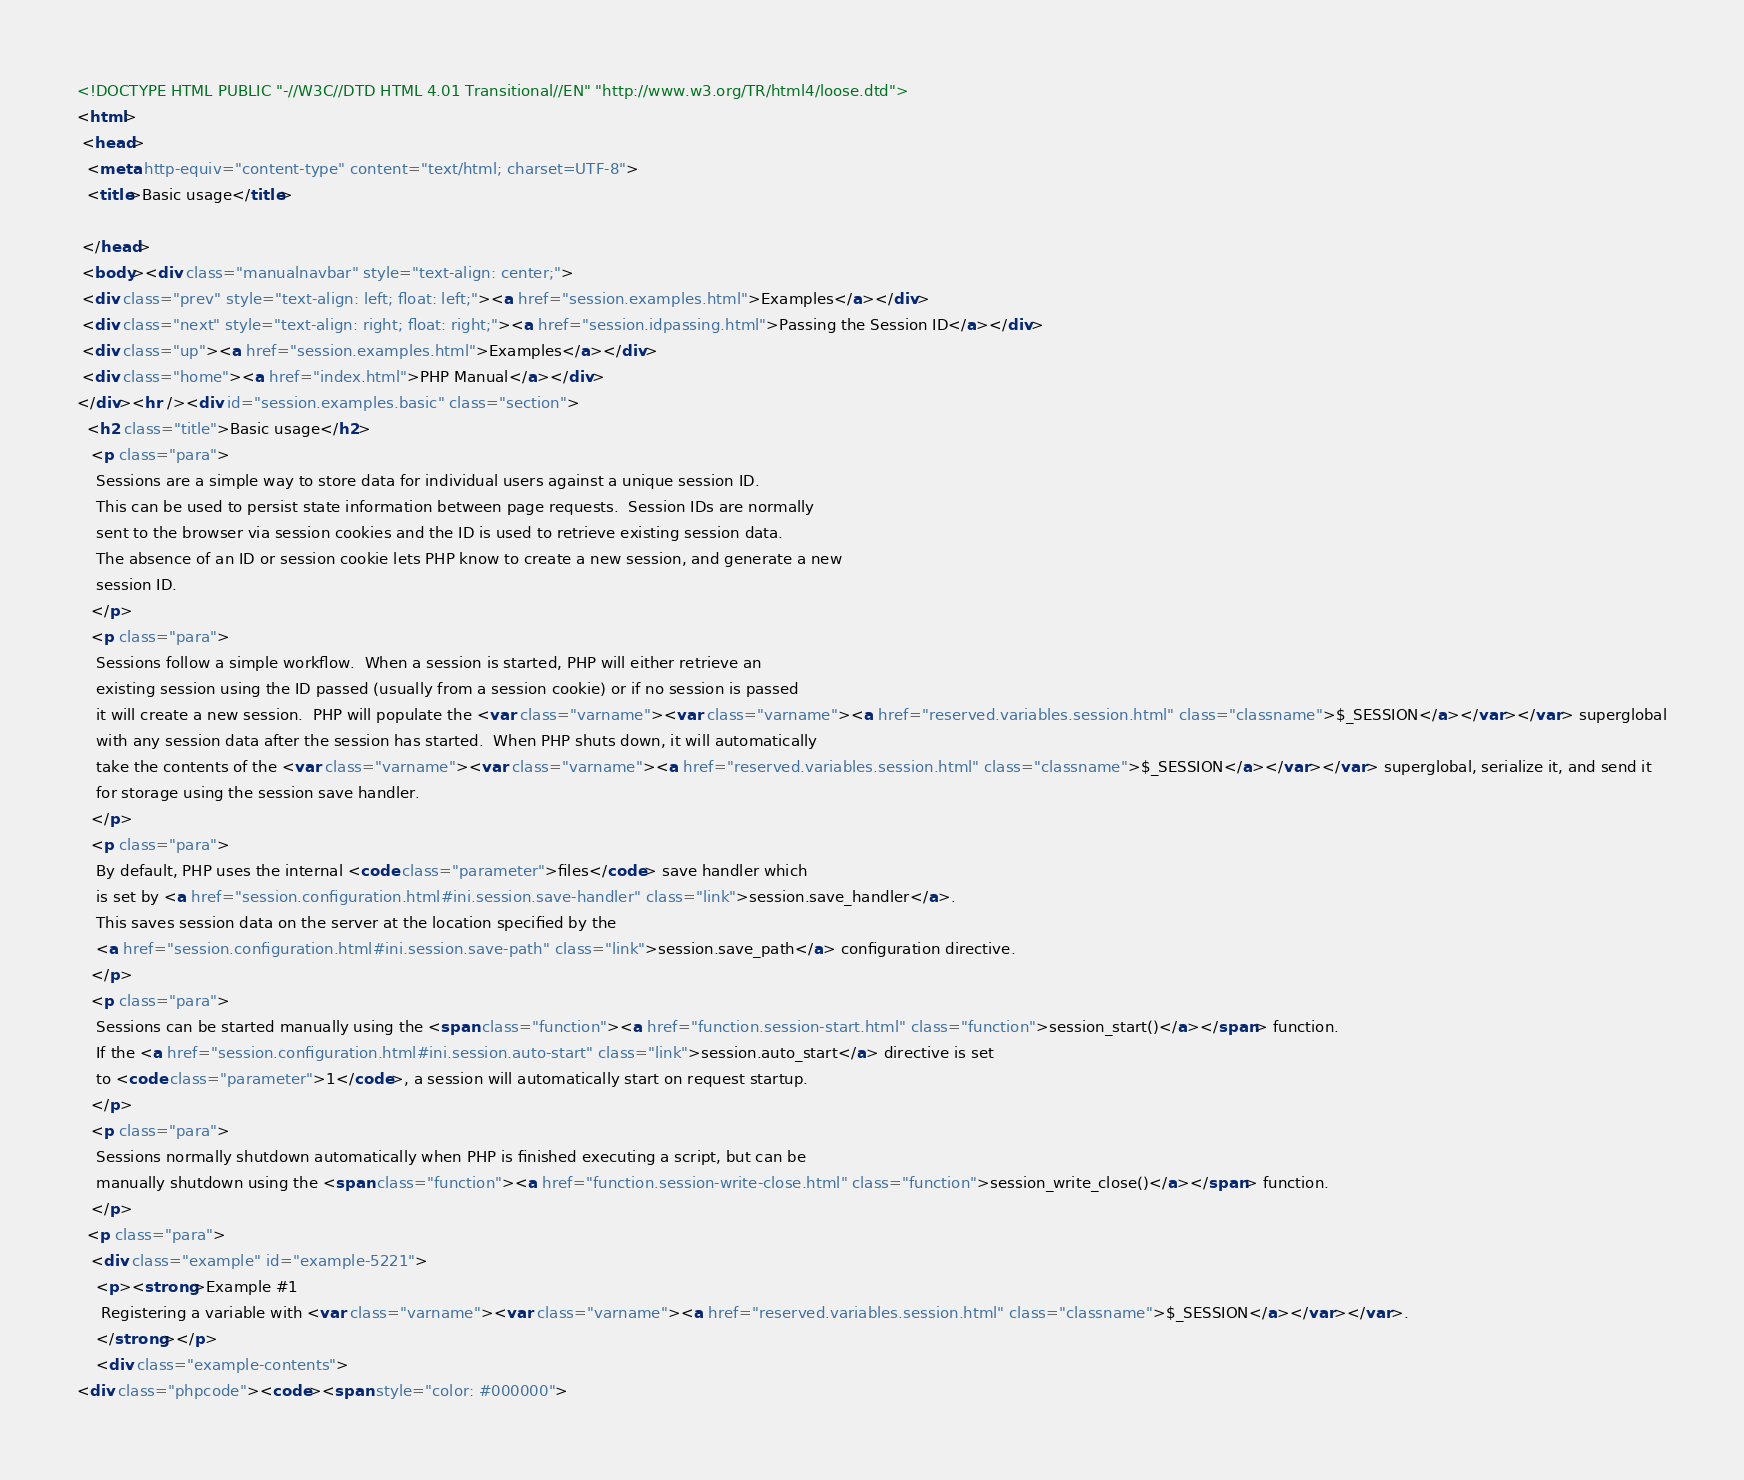<code> <loc_0><loc_0><loc_500><loc_500><_HTML_><!DOCTYPE HTML PUBLIC "-//W3C//DTD HTML 4.01 Transitional//EN" "http://www.w3.org/TR/html4/loose.dtd">
<html>
 <head>
  <meta http-equiv="content-type" content="text/html; charset=UTF-8">
  <title>Basic usage</title>

 </head>
 <body><div class="manualnavbar" style="text-align: center;">
 <div class="prev" style="text-align: left; float: left;"><a href="session.examples.html">Examples</a></div>
 <div class="next" style="text-align: right; float: right;"><a href="session.idpassing.html">Passing the Session ID</a></div>
 <div class="up"><a href="session.examples.html">Examples</a></div>
 <div class="home"><a href="index.html">PHP Manual</a></div>
</div><hr /><div id="session.examples.basic" class="section">
  <h2 class="title">Basic usage</h2>
   <p class="para">
    Sessions are a simple way to store data for individual users against a unique session ID.
    This can be used to persist state information between page requests.  Session IDs are normally
    sent to the browser via session cookies and the ID is used to retrieve existing session data.
    The absence of an ID or session cookie lets PHP know to create a new session, and generate a new
    session ID.
   </p>
   <p class="para">
    Sessions follow a simple workflow.  When a session is started, PHP will either retrieve an
    existing session using the ID passed (usually from a session cookie) or if no session is passed
    it will create a new session.  PHP will populate the <var class="varname"><var class="varname"><a href="reserved.variables.session.html" class="classname">$_SESSION</a></var></var> superglobal
    with any session data after the session has started.  When PHP shuts down, it will automatically
    take the contents of the <var class="varname"><var class="varname"><a href="reserved.variables.session.html" class="classname">$_SESSION</a></var></var> superglobal, serialize it, and send it
    for storage using the session save handler.
   </p>
   <p class="para">
    By default, PHP uses the internal <code class="parameter">files</code> save handler which
    is set by <a href="session.configuration.html#ini.session.save-handler" class="link">session.save_handler</a>.
    This saves session data on the server at the location specified by the
    <a href="session.configuration.html#ini.session.save-path" class="link">session.save_path</a> configuration directive.
   </p>
   <p class="para">
    Sessions can be started manually using the <span class="function"><a href="function.session-start.html" class="function">session_start()</a></span> function.
    If the <a href="session.configuration.html#ini.session.auto-start" class="link">session.auto_start</a> directive is set
    to <code class="parameter">1</code>, a session will automatically start on request startup.
   </p>
   <p class="para">
    Sessions normally shutdown automatically when PHP is finished executing a script, but can be
    manually shutdown using the <span class="function"><a href="function.session-write-close.html" class="function">session_write_close()</a></span> function.
   </p>
  <p class="para">
   <div class="example" id="example-5221">
    <p><strong>Example #1 
     Registering a variable with <var class="varname"><var class="varname"><a href="reserved.variables.session.html" class="classname">$_SESSION</a></var></var>.
    </strong></p>
    <div class="example-contents">
<div class="phpcode"><code><span style="color: #000000"></code> 